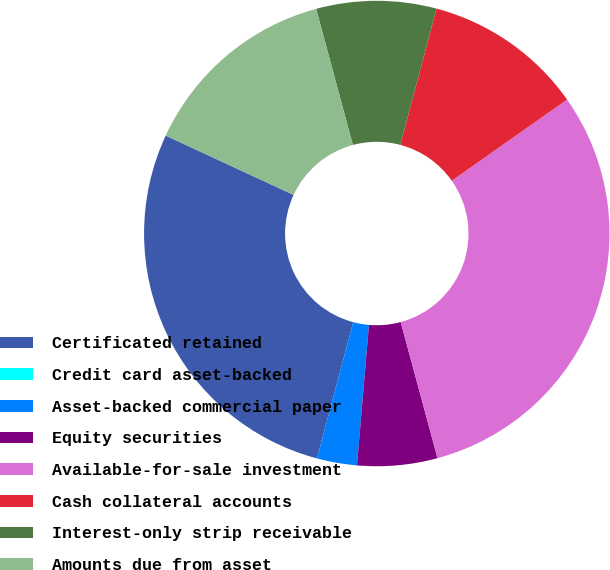Convert chart to OTSL. <chart><loc_0><loc_0><loc_500><loc_500><pie_chart><fcel>Certificated retained<fcel>Credit card asset-backed<fcel>Asset-backed commercial paper<fcel>Equity securities<fcel>Available-for-sale investment<fcel>Cash collateral accounts<fcel>Interest-only strip receivable<fcel>Amounts due from asset<nl><fcel>27.78%<fcel>0.0%<fcel>2.78%<fcel>5.56%<fcel>30.56%<fcel>11.11%<fcel>8.33%<fcel>13.89%<nl></chart> 